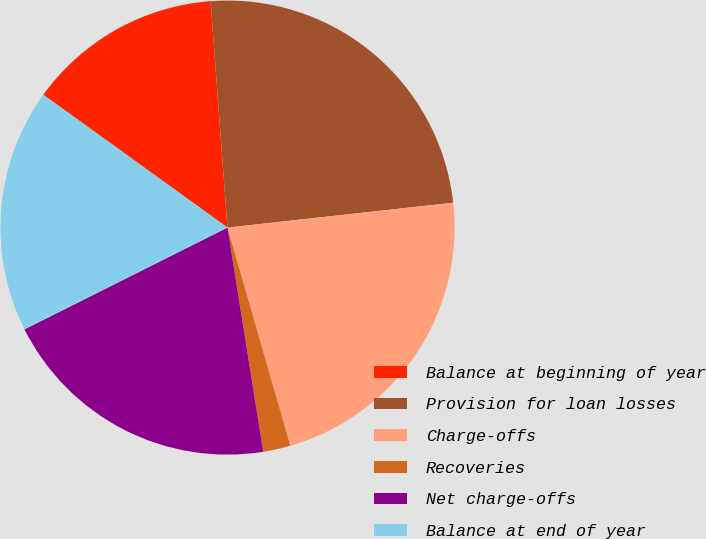Convert chart to OTSL. <chart><loc_0><loc_0><loc_500><loc_500><pie_chart><fcel>Balance at beginning of year<fcel>Provision for loan losses<fcel>Charge-offs<fcel>Recoveries<fcel>Net charge-offs<fcel>Balance at end of year<nl><fcel>13.87%<fcel>24.44%<fcel>22.28%<fcel>1.95%<fcel>20.12%<fcel>17.34%<nl></chart> 